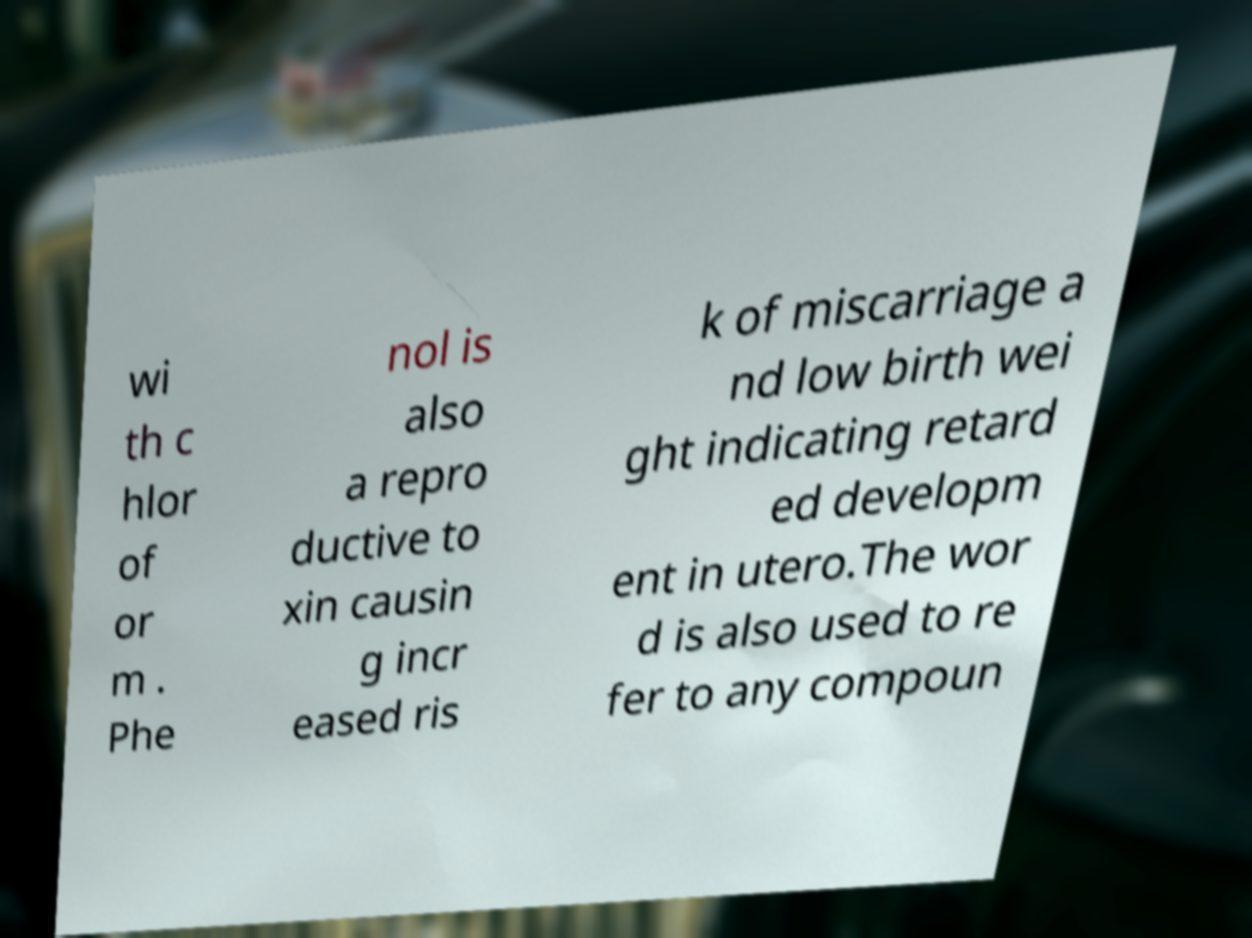Please read and relay the text visible in this image. What does it say? wi th c hlor of or m . Phe nol is also a repro ductive to xin causin g incr eased ris k of miscarriage a nd low birth wei ght indicating retard ed developm ent in utero.The wor d is also used to re fer to any compoun 